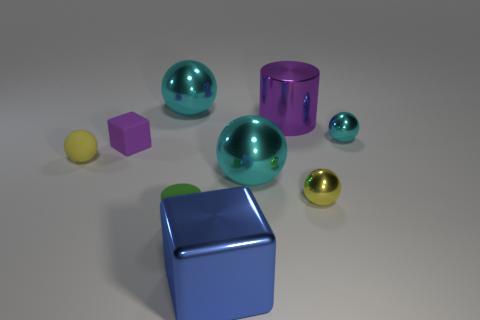Subtract all cyan spheres. How many were subtracted if there are1cyan spheres left? 2 Subtract all green blocks. How many cyan balls are left? 3 Subtract 2 spheres. How many spheres are left? 3 Subtract all brown balls. Subtract all blue cylinders. How many balls are left? 5 Add 1 tiny things. How many objects exist? 10 Subtract all spheres. How many objects are left? 4 Add 1 large cylinders. How many large cylinders exist? 2 Subtract 0 brown blocks. How many objects are left? 9 Subtract all small purple rubber things. Subtract all tiny yellow rubber spheres. How many objects are left? 7 Add 8 metal cylinders. How many metal cylinders are left? 9 